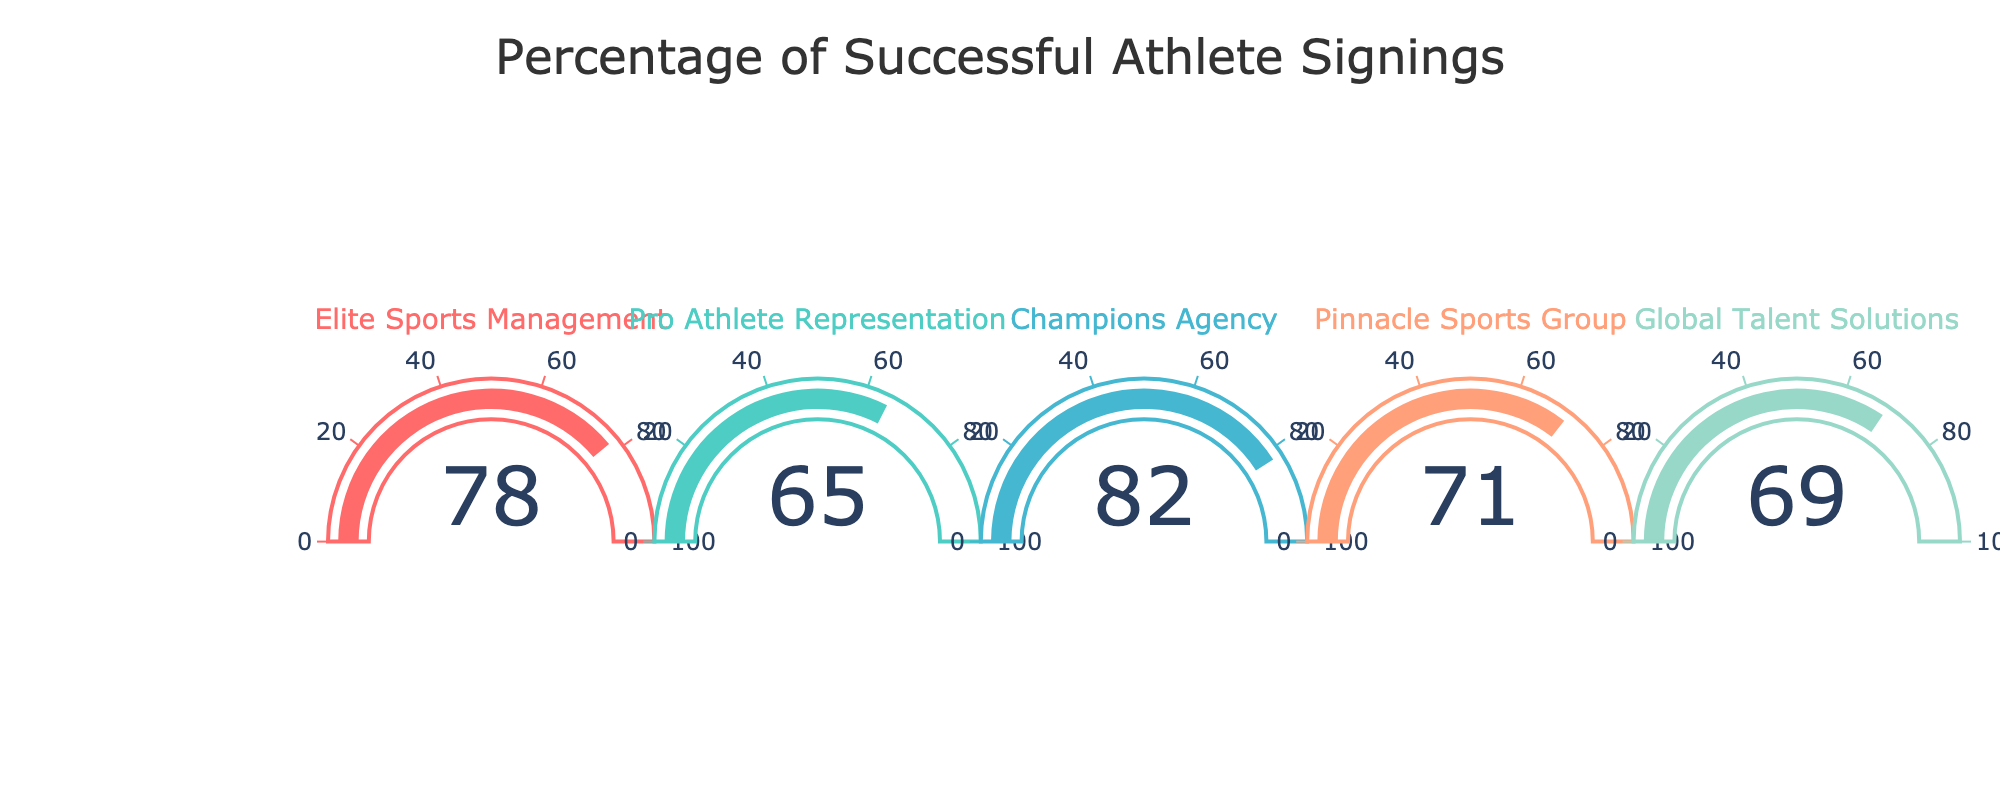What's the title of the figure? The title is displayed at the top of the figure, which says "Percentage of Successful Athlete Signings".
Answer: Percentage of Successful Athlete Signings How many agencies are represented in the figure? By counting the number of gauges, we can see there are five.
Answer: Five Which agency has the highest percentage of successful signings? By comparing the values on each gauge, we observe that Champions Agency has the highest value at 82%.
Answer: Champions Agency What's the percentage of successful signings for Pinnacle Sports Group? The value displayed on the gauge for Pinnacle Sports Group is 71%.
Answer: 71% What's the difference in successful signing percentages between Champions Agency and Pro Athlete Representation? Subtracting Pro Athlete Representation's percentage (65%) from Champions Agency's percentage (82%) gives 82 - 65 = 17%.
Answer: 17% What's the average percentage of successful signings across all agencies? Adding the percentages of all five agencies (78 + 65 + 82 + 71 + 69) results in 365, which when divided by 5 is 365/5 = 73%.
Answer: 73% Which agency has a successful signing percentage that falls in the range of 50-75%? Looking at the values, both Pro Athlete Representation (65%) and Global Talent Solutions (69%) fall within the range of 50-75%.
Answer: Pro Athlete Representation, Global Talent Solutions Which agencies have a successful signing percentage greater than or equal to 75%? Comparing all values, Elite Sports Management (78%) and Champions Agency (82%) meet the criteria.
Answer: Elite Sports Management, Champions Agency What is the median percentage of successful signings? Arranging the percentages in ascending order: 65, 69, 71, 78, 82, the median is the middle value, which is 71%.
Answer: 71% What's the percentage difference between the two agencies with the lowest signings? The agencies with the lowest values are Pro Athlete Representation (65%) and Global Talent Solutions (69%). The difference is 69 - 65 = 4%.
Answer: 4% 